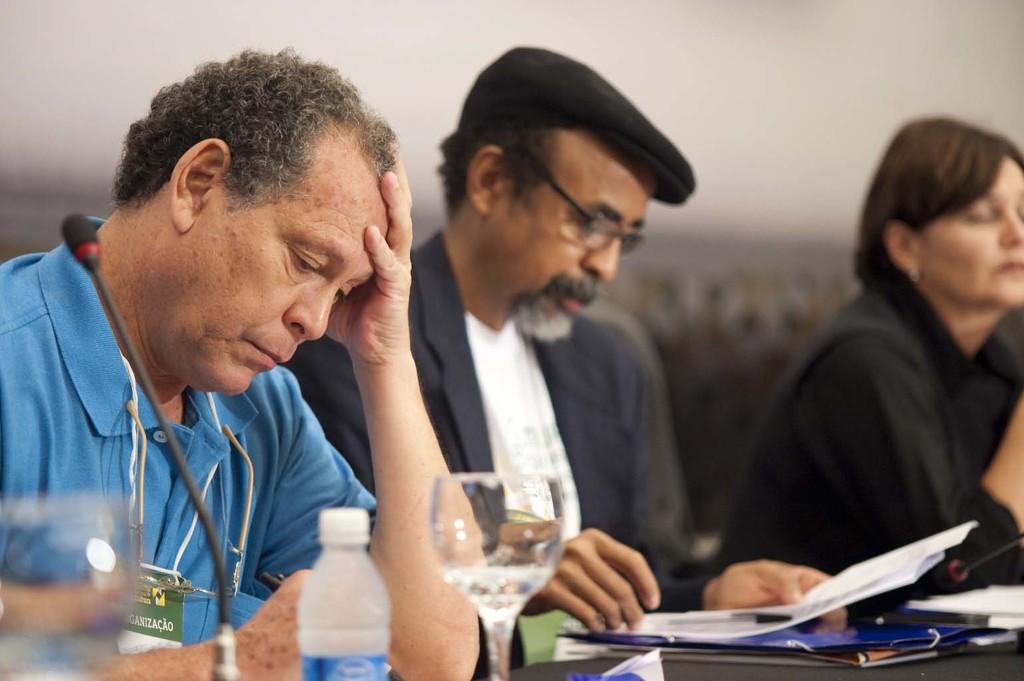Describe this image in one or two sentences. Here in this picture we can see three people sitting on chairs with table in front of them, having some files, papers, pens and glasses and bottles present on it and we can see the person in the front is wearing an ID card and the person in the middle is wearing a coat with spectacles and cap on him and the woman is in blurry manner beside him. 